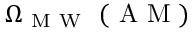<formula> <loc_0><loc_0><loc_500><loc_500>\Omega _ { M W } ( A M )</formula> 